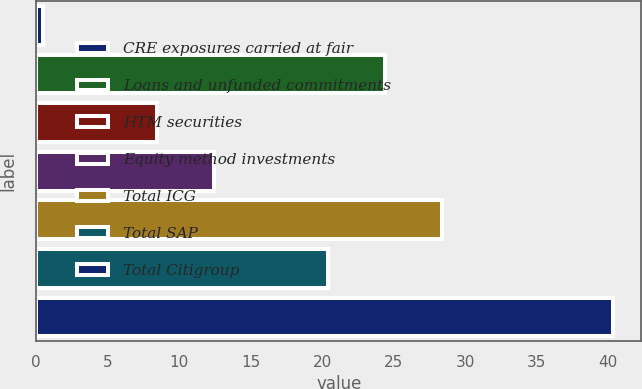Convert chart. <chart><loc_0><loc_0><loc_500><loc_500><bar_chart><fcel>CRE exposures carried at fair<fcel>Loans and unfunded commitments<fcel>HTM securities<fcel>Equity method investments<fcel>Total ICG<fcel>Total SAP<fcel>Total Citigroup<nl><fcel>0.5<fcel>24.38<fcel>8.46<fcel>12.44<fcel>28.36<fcel>20.4<fcel>40.3<nl></chart> 